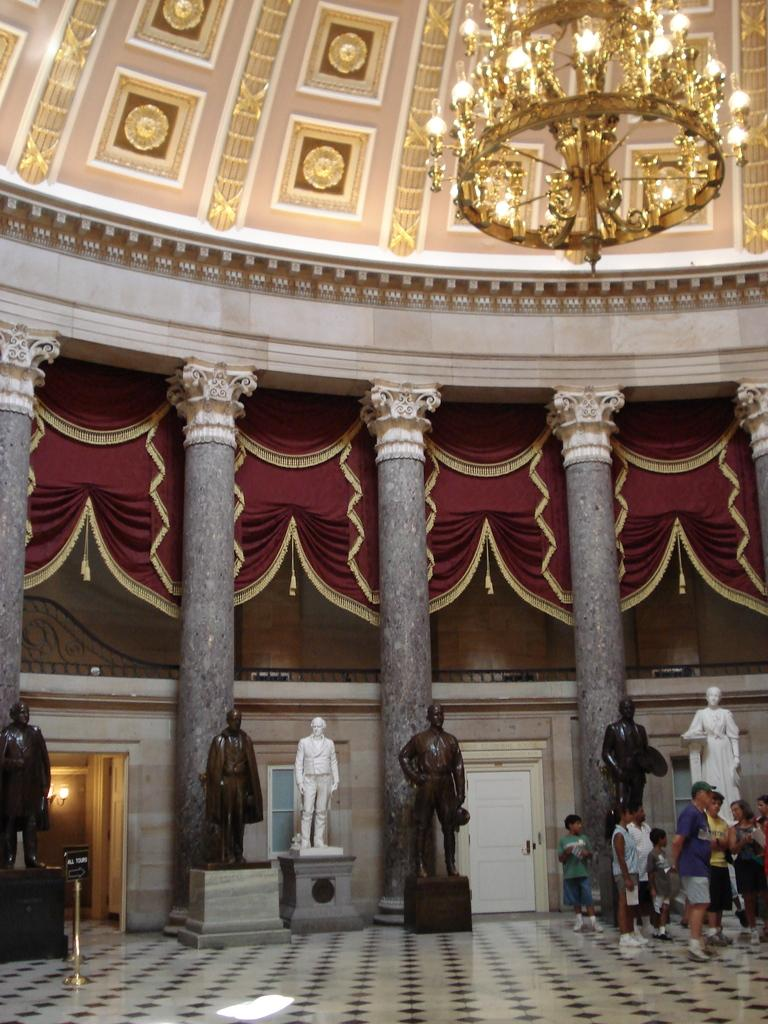What type of location is depicted in the image? The image shows an inside view of a building. What decorative elements can be seen in the image? There are statues in the image. Who or what is present in the image? There is a group of people in the image. What type of window treatment is visible in the image? There are curtains in the image. What provides illumination in the image? There are lights in the image. What type of cake is being served to the people in the image? There is no cake present in the image; it only shows a group of people in an indoor setting with statues, curtains, and lights. 